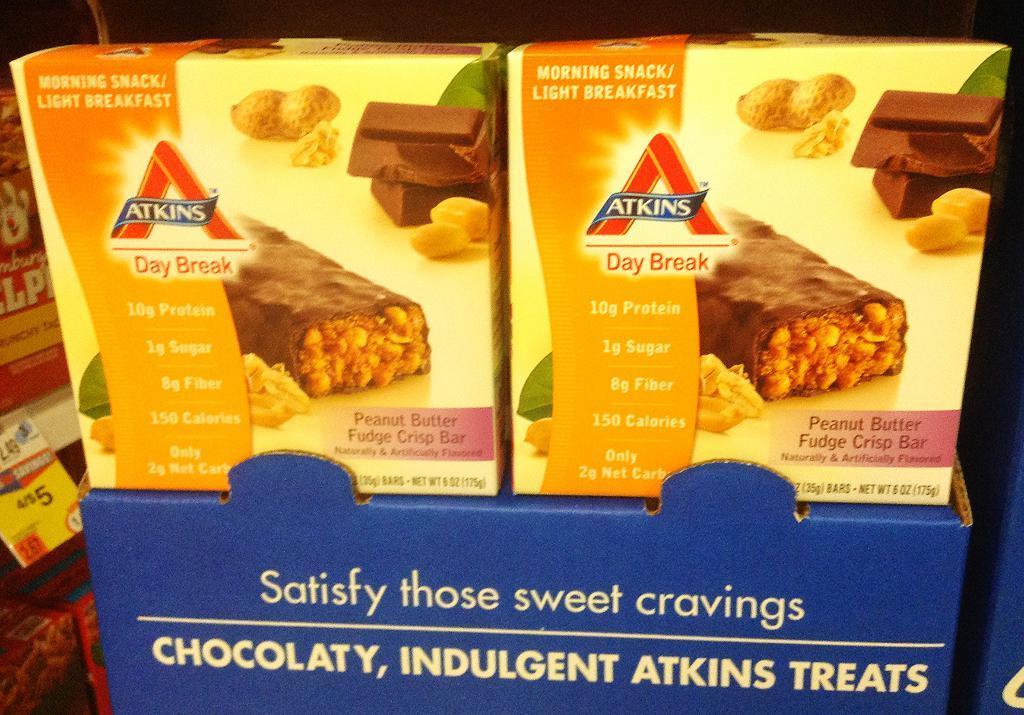Please provide a concise description of this image. In the image we can see there are chocolate bar boxes kept on the cardboard box and its written ¨ATKINS¨ on the chocolate bar boxes. 